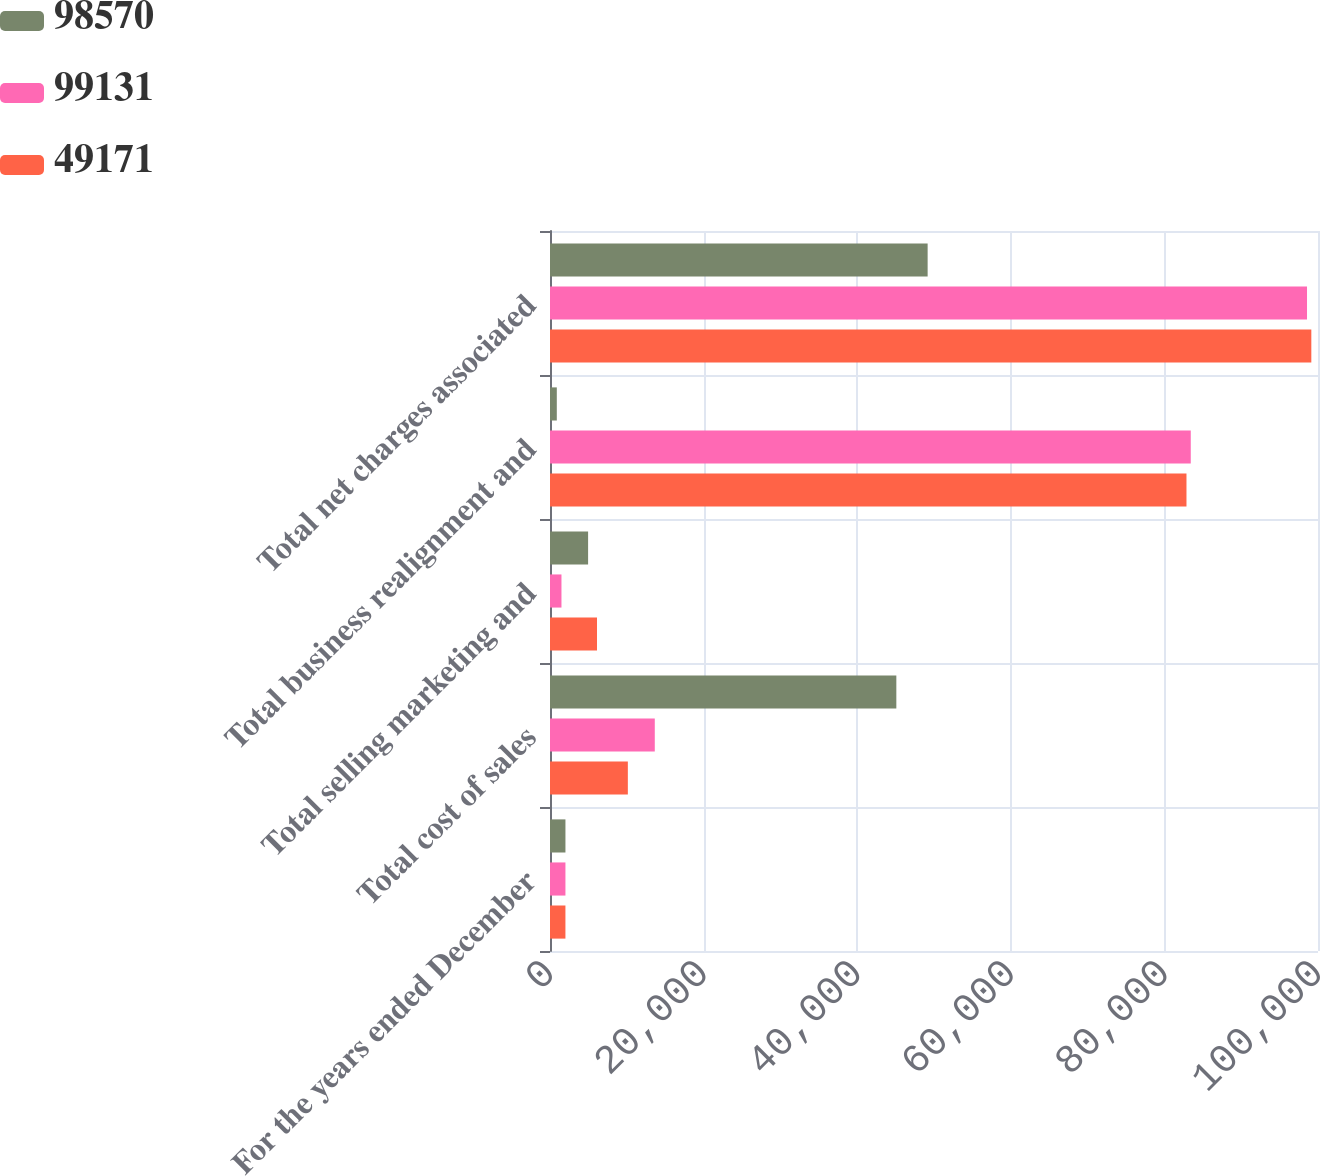<chart> <loc_0><loc_0><loc_500><loc_500><stacked_bar_chart><ecel><fcel>For the years ended December<fcel>Total cost of sales<fcel>Total selling marketing and<fcel>Total business realignment and<fcel>Total net charges associated<nl><fcel>98570<fcel>2011<fcel>45096<fcel>4961<fcel>886<fcel>49171<nl><fcel>99131<fcel>2010<fcel>13644<fcel>1493<fcel>83433<fcel>98570<nl><fcel>49171<fcel>2009<fcel>10136<fcel>6120<fcel>82875<fcel>99131<nl></chart> 